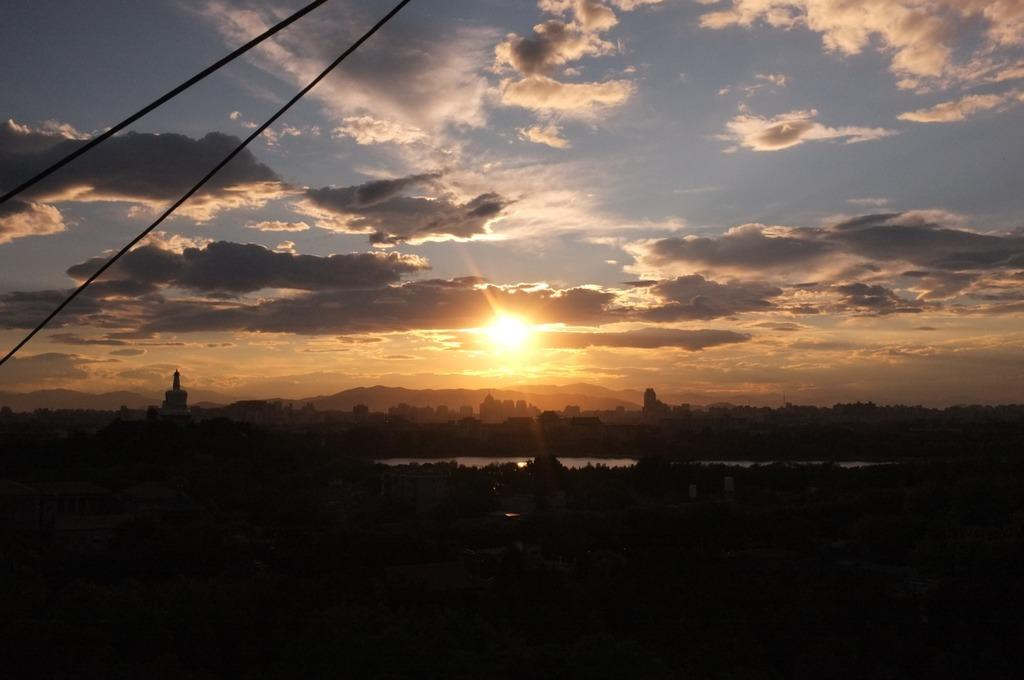What is the color of the bottom part of the image? The bottom of the image is dark. What type of natural elements can be seen in the image? There are trees and water visible in the image. What type of man-made structures are present in the image? There are buildings in the image. What can be seen in the sky in the image? The sky is visible at the top of the image, and it contains the sun and clouds. Are there any additional details in the top left corner of the image? Yes, there are two wires in the top left corner of the image. What type of wine is being poured into the glass in the image? There is no wine or glass present in the image. What riddle is being solved by the person in the image? There is no person or riddle present in the image. 